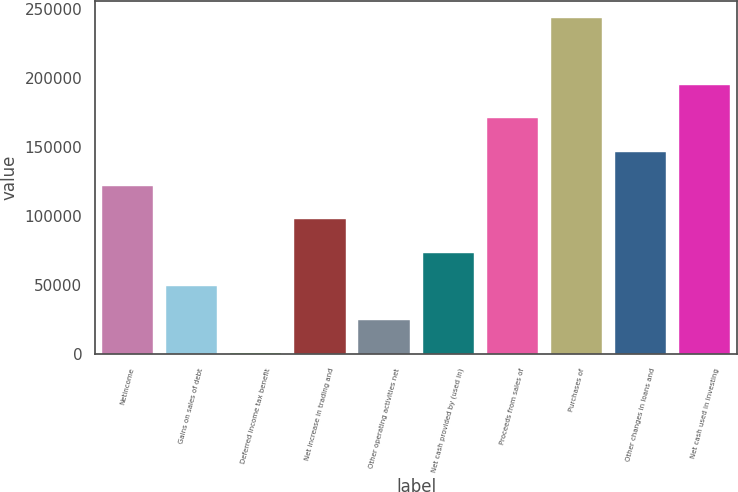Convert chart. <chart><loc_0><loc_0><loc_500><loc_500><bar_chart><fcel>Netincome<fcel>Gains on sales of debt<fcel>Deferred income tax benefit<fcel>Net increase in trading and<fcel>Other operating activities net<fcel>Net cash provided by (used in)<fcel>Proceeds from sales of<fcel>Purchases of<fcel>Other changes in loans and<fcel>Net cash used in investing<nl><fcel>122046<fcel>49129.8<fcel>519<fcel>97740.6<fcel>24824.4<fcel>73435.2<fcel>170657<fcel>243573<fcel>146351<fcel>194962<nl></chart> 